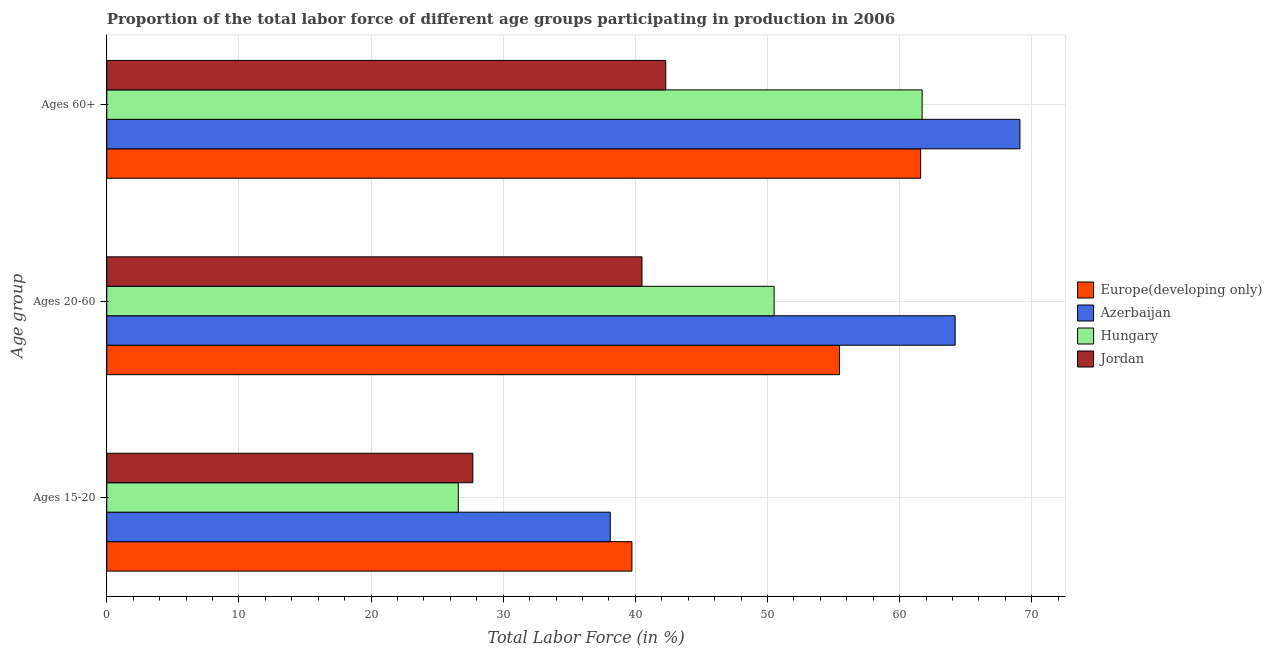How many different coloured bars are there?
Your answer should be very brief. 4. How many bars are there on the 3rd tick from the bottom?
Offer a terse response. 4. What is the label of the 1st group of bars from the top?
Provide a short and direct response. Ages 60+. What is the percentage of labor force above age 60 in Europe(developing only)?
Give a very brief answer. 61.59. Across all countries, what is the maximum percentage of labor force within the age group 15-20?
Provide a short and direct response. 39.74. Across all countries, what is the minimum percentage of labor force within the age group 20-60?
Your answer should be compact. 40.5. In which country was the percentage of labor force above age 60 maximum?
Offer a very short reply. Azerbaijan. In which country was the percentage of labor force within the age group 20-60 minimum?
Offer a very short reply. Jordan. What is the total percentage of labor force above age 60 in the graph?
Provide a short and direct response. 234.69. What is the difference between the percentage of labor force within the age group 15-20 in Azerbaijan and that in Europe(developing only)?
Ensure brevity in your answer.  -1.64. What is the difference between the percentage of labor force within the age group 20-60 in Azerbaijan and the percentage of labor force within the age group 15-20 in Jordan?
Your response must be concise. 36.5. What is the average percentage of labor force above age 60 per country?
Give a very brief answer. 58.67. What is the difference between the percentage of labor force within the age group 15-20 and percentage of labor force within the age group 20-60 in Hungary?
Offer a very short reply. -23.9. In how many countries, is the percentage of labor force above age 60 greater than 28 %?
Offer a very short reply. 4. What is the ratio of the percentage of labor force above age 60 in Azerbaijan to that in Jordan?
Your answer should be very brief. 1.63. What is the difference between the highest and the second highest percentage of labor force within the age group 15-20?
Provide a short and direct response. 1.64. What is the difference between the highest and the lowest percentage of labor force above age 60?
Offer a very short reply. 26.8. In how many countries, is the percentage of labor force within the age group 20-60 greater than the average percentage of labor force within the age group 20-60 taken over all countries?
Your answer should be very brief. 2. What does the 3rd bar from the top in Ages 15-20 represents?
Offer a very short reply. Azerbaijan. What does the 2nd bar from the bottom in Ages 60+ represents?
Your answer should be very brief. Azerbaijan. Are all the bars in the graph horizontal?
Your answer should be compact. Yes. Are the values on the major ticks of X-axis written in scientific E-notation?
Offer a terse response. No. Does the graph contain grids?
Offer a very short reply. Yes. What is the title of the graph?
Offer a very short reply. Proportion of the total labor force of different age groups participating in production in 2006. Does "Burkina Faso" appear as one of the legend labels in the graph?
Give a very brief answer. No. What is the label or title of the Y-axis?
Make the answer very short. Age group. What is the Total Labor Force (in %) of Europe(developing only) in Ages 15-20?
Provide a succinct answer. 39.74. What is the Total Labor Force (in %) in Azerbaijan in Ages 15-20?
Your answer should be very brief. 38.1. What is the Total Labor Force (in %) in Hungary in Ages 15-20?
Keep it short and to the point. 26.6. What is the Total Labor Force (in %) in Jordan in Ages 15-20?
Your response must be concise. 27.7. What is the Total Labor Force (in %) of Europe(developing only) in Ages 20-60?
Offer a terse response. 55.45. What is the Total Labor Force (in %) of Azerbaijan in Ages 20-60?
Ensure brevity in your answer.  64.2. What is the Total Labor Force (in %) in Hungary in Ages 20-60?
Keep it short and to the point. 50.5. What is the Total Labor Force (in %) in Jordan in Ages 20-60?
Your answer should be compact. 40.5. What is the Total Labor Force (in %) of Europe(developing only) in Ages 60+?
Provide a short and direct response. 61.59. What is the Total Labor Force (in %) of Azerbaijan in Ages 60+?
Keep it short and to the point. 69.1. What is the Total Labor Force (in %) in Hungary in Ages 60+?
Your response must be concise. 61.7. What is the Total Labor Force (in %) in Jordan in Ages 60+?
Your answer should be compact. 42.3. Across all Age group, what is the maximum Total Labor Force (in %) of Europe(developing only)?
Your answer should be very brief. 61.59. Across all Age group, what is the maximum Total Labor Force (in %) in Azerbaijan?
Give a very brief answer. 69.1. Across all Age group, what is the maximum Total Labor Force (in %) of Hungary?
Keep it short and to the point. 61.7. Across all Age group, what is the maximum Total Labor Force (in %) of Jordan?
Give a very brief answer. 42.3. Across all Age group, what is the minimum Total Labor Force (in %) of Europe(developing only)?
Offer a terse response. 39.74. Across all Age group, what is the minimum Total Labor Force (in %) in Azerbaijan?
Provide a succinct answer. 38.1. Across all Age group, what is the minimum Total Labor Force (in %) of Hungary?
Your answer should be very brief. 26.6. Across all Age group, what is the minimum Total Labor Force (in %) in Jordan?
Your answer should be compact. 27.7. What is the total Total Labor Force (in %) of Europe(developing only) in the graph?
Your response must be concise. 156.78. What is the total Total Labor Force (in %) of Azerbaijan in the graph?
Ensure brevity in your answer.  171.4. What is the total Total Labor Force (in %) of Hungary in the graph?
Provide a succinct answer. 138.8. What is the total Total Labor Force (in %) of Jordan in the graph?
Make the answer very short. 110.5. What is the difference between the Total Labor Force (in %) in Europe(developing only) in Ages 15-20 and that in Ages 20-60?
Provide a succinct answer. -15.71. What is the difference between the Total Labor Force (in %) in Azerbaijan in Ages 15-20 and that in Ages 20-60?
Ensure brevity in your answer.  -26.1. What is the difference between the Total Labor Force (in %) in Hungary in Ages 15-20 and that in Ages 20-60?
Provide a succinct answer. -23.9. What is the difference between the Total Labor Force (in %) of Europe(developing only) in Ages 15-20 and that in Ages 60+?
Your answer should be very brief. -21.85. What is the difference between the Total Labor Force (in %) in Azerbaijan in Ages 15-20 and that in Ages 60+?
Offer a very short reply. -31. What is the difference between the Total Labor Force (in %) of Hungary in Ages 15-20 and that in Ages 60+?
Keep it short and to the point. -35.1. What is the difference between the Total Labor Force (in %) in Jordan in Ages 15-20 and that in Ages 60+?
Your answer should be very brief. -14.6. What is the difference between the Total Labor Force (in %) of Europe(developing only) in Ages 20-60 and that in Ages 60+?
Keep it short and to the point. -6.14. What is the difference between the Total Labor Force (in %) of Azerbaijan in Ages 20-60 and that in Ages 60+?
Your answer should be compact. -4.9. What is the difference between the Total Labor Force (in %) in Hungary in Ages 20-60 and that in Ages 60+?
Offer a very short reply. -11.2. What is the difference between the Total Labor Force (in %) in Europe(developing only) in Ages 15-20 and the Total Labor Force (in %) in Azerbaijan in Ages 20-60?
Give a very brief answer. -24.46. What is the difference between the Total Labor Force (in %) of Europe(developing only) in Ages 15-20 and the Total Labor Force (in %) of Hungary in Ages 20-60?
Give a very brief answer. -10.76. What is the difference between the Total Labor Force (in %) in Europe(developing only) in Ages 15-20 and the Total Labor Force (in %) in Jordan in Ages 20-60?
Provide a short and direct response. -0.76. What is the difference between the Total Labor Force (in %) of Europe(developing only) in Ages 15-20 and the Total Labor Force (in %) of Azerbaijan in Ages 60+?
Make the answer very short. -29.36. What is the difference between the Total Labor Force (in %) in Europe(developing only) in Ages 15-20 and the Total Labor Force (in %) in Hungary in Ages 60+?
Provide a short and direct response. -21.96. What is the difference between the Total Labor Force (in %) of Europe(developing only) in Ages 15-20 and the Total Labor Force (in %) of Jordan in Ages 60+?
Provide a short and direct response. -2.56. What is the difference between the Total Labor Force (in %) of Azerbaijan in Ages 15-20 and the Total Labor Force (in %) of Hungary in Ages 60+?
Make the answer very short. -23.6. What is the difference between the Total Labor Force (in %) of Azerbaijan in Ages 15-20 and the Total Labor Force (in %) of Jordan in Ages 60+?
Your answer should be very brief. -4.2. What is the difference between the Total Labor Force (in %) of Hungary in Ages 15-20 and the Total Labor Force (in %) of Jordan in Ages 60+?
Your response must be concise. -15.7. What is the difference between the Total Labor Force (in %) in Europe(developing only) in Ages 20-60 and the Total Labor Force (in %) in Azerbaijan in Ages 60+?
Provide a short and direct response. -13.65. What is the difference between the Total Labor Force (in %) of Europe(developing only) in Ages 20-60 and the Total Labor Force (in %) of Hungary in Ages 60+?
Provide a short and direct response. -6.25. What is the difference between the Total Labor Force (in %) in Europe(developing only) in Ages 20-60 and the Total Labor Force (in %) in Jordan in Ages 60+?
Provide a short and direct response. 13.15. What is the difference between the Total Labor Force (in %) of Azerbaijan in Ages 20-60 and the Total Labor Force (in %) of Jordan in Ages 60+?
Give a very brief answer. 21.9. What is the average Total Labor Force (in %) in Europe(developing only) per Age group?
Make the answer very short. 52.26. What is the average Total Labor Force (in %) of Azerbaijan per Age group?
Ensure brevity in your answer.  57.13. What is the average Total Labor Force (in %) in Hungary per Age group?
Give a very brief answer. 46.27. What is the average Total Labor Force (in %) of Jordan per Age group?
Your answer should be very brief. 36.83. What is the difference between the Total Labor Force (in %) in Europe(developing only) and Total Labor Force (in %) in Azerbaijan in Ages 15-20?
Make the answer very short. 1.64. What is the difference between the Total Labor Force (in %) of Europe(developing only) and Total Labor Force (in %) of Hungary in Ages 15-20?
Make the answer very short. 13.14. What is the difference between the Total Labor Force (in %) of Europe(developing only) and Total Labor Force (in %) of Jordan in Ages 15-20?
Give a very brief answer. 12.04. What is the difference between the Total Labor Force (in %) of Azerbaijan and Total Labor Force (in %) of Hungary in Ages 15-20?
Make the answer very short. 11.5. What is the difference between the Total Labor Force (in %) of Azerbaijan and Total Labor Force (in %) of Jordan in Ages 15-20?
Ensure brevity in your answer.  10.4. What is the difference between the Total Labor Force (in %) of Europe(developing only) and Total Labor Force (in %) of Azerbaijan in Ages 20-60?
Give a very brief answer. -8.75. What is the difference between the Total Labor Force (in %) of Europe(developing only) and Total Labor Force (in %) of Hungary in Ages 20-60?
Give a very brief answer. 4.95. What is the difference between the Total Labor Force (in %) in Europe(developing only) and Total Labor Force (in %) in Jordan in Ages 20-60?
Your answer should be very brief. 14.95. What is the difference between the Total Labor Force (in %) of Azerbaijan and Total Labor Force (in %) of Hungary in Ages 20-60?
Offer a terse response. 13.7. What is the difference between the Total Labor Force (in %) of Azerbaijan and Total Labor Force (in %) of Jordan in Ages 20-60?
Provide a succinct answer. 23.7. What is the difference between the Total Labor Force (in %) of Europe(developing only) and Total Labor Force (in %) of Azerbaijan in Ages 60+?
Keep it short and to the point. -7.51. What is the difference between the Total Labor Force (in %) in Europe(developing only) and Total Labor Force (in %) in Hungary in Ages 60+?
Offer a very short reply. -0.11. What is the difference between the Total Labor Force (in %) in Europe(developing only) and Total Labor Force (in %) in Jordan in Ages 60+?
Offer a very short reply. 19.29. What is the difference between the Total Labor Force (in %) of Azerbaijan and Total Labor Force (in %) of Jordan in Ages 60+?
Make the answer very short. 26.8. What is the difference between the Total Labor Force (in %) of Hungary and Total Labor Force (in %) of Jordan in Ages 60+?
Make the answer very short. 19.4. What is the ratio of the Total Labor Force (in %) in Europe(developing only) in Ages 15-20 to that in Ages 20-60?
Provide a short and direct response. 0.72. What is the ratio of the Total Labor Force (in %) of Azerbaijan in Ages 15-20 to that in Ages 20-60?
Provide a short and direct response. 0.59. What is the ratio of the Total Labor Force (in %) in Hungary in Ages 15-20 to that in Ages 20-60?
Provide a short and direct response. 0.53. What is the ratio of the Total Labor Force (in %) in Jordan in Ages 15-20 to that in Ages 20-60?
Your answer should be very brief. 0.68. What is the ratio of the Total Labor Force (in %) of Europe(developing only) in Ages 15-20 to that in Ages 60+?
Ensure brevity in your answer.  0.65. What is the ratio of the Total Labor Force (in %) in Azerbaijan in Ages 15-20 to that in Ages 60+?
Provide a succinct answer. 0.55. What is the ratio of the Total Labor Force (in %) in Hungary in Ages 15-20 to that in Ages 60+?
Your answer should be very brief. 0.43. What is the ratio of the Total Labor Force (in %) of Jordan in Ages 15-20 to that in Ages 60+?
Offer a very short reply. 0.65. What is the ratio of the Total Labor Force (in %) of Europe(developing only) in Ages 20-60 to that in Ages 60+?
Provide a succinct answer. 0.9. What is the ratio of the Total Labor Force (in %) in Azerbaijan in Ages 20-60 to that in Ages 60+?
Provide a short and direct response. 0.93. What is the ratio of the Total Labor Force (in %) in Hungary in Ages 20-60 to that in Ages 60+?
Keep it short and to the point. 0.82. What is the ratio of the Total Labor Force (in %) in Jordan in Ages 20-60 to that in Ages 60+?
Offer a very short reply. 0.96. What is the difference between the highest and the second highest Total Labor Force (in %) in Europe(developing only)?
Your response must be concise. 6.14. What is the difference between the highest and the second highest Total Labor Force (in %) of Hungary?
Offer a very short reply. 11.2. What is the difference between the highest and the lowest Total Labor Force (in %) in Europe(developing only)?
Give a very brief answer. 21.85. What is the difference between the highest and the lowest Total Labor Force (in %) of Hungary?
Your answer should be very brief. 35.1. 